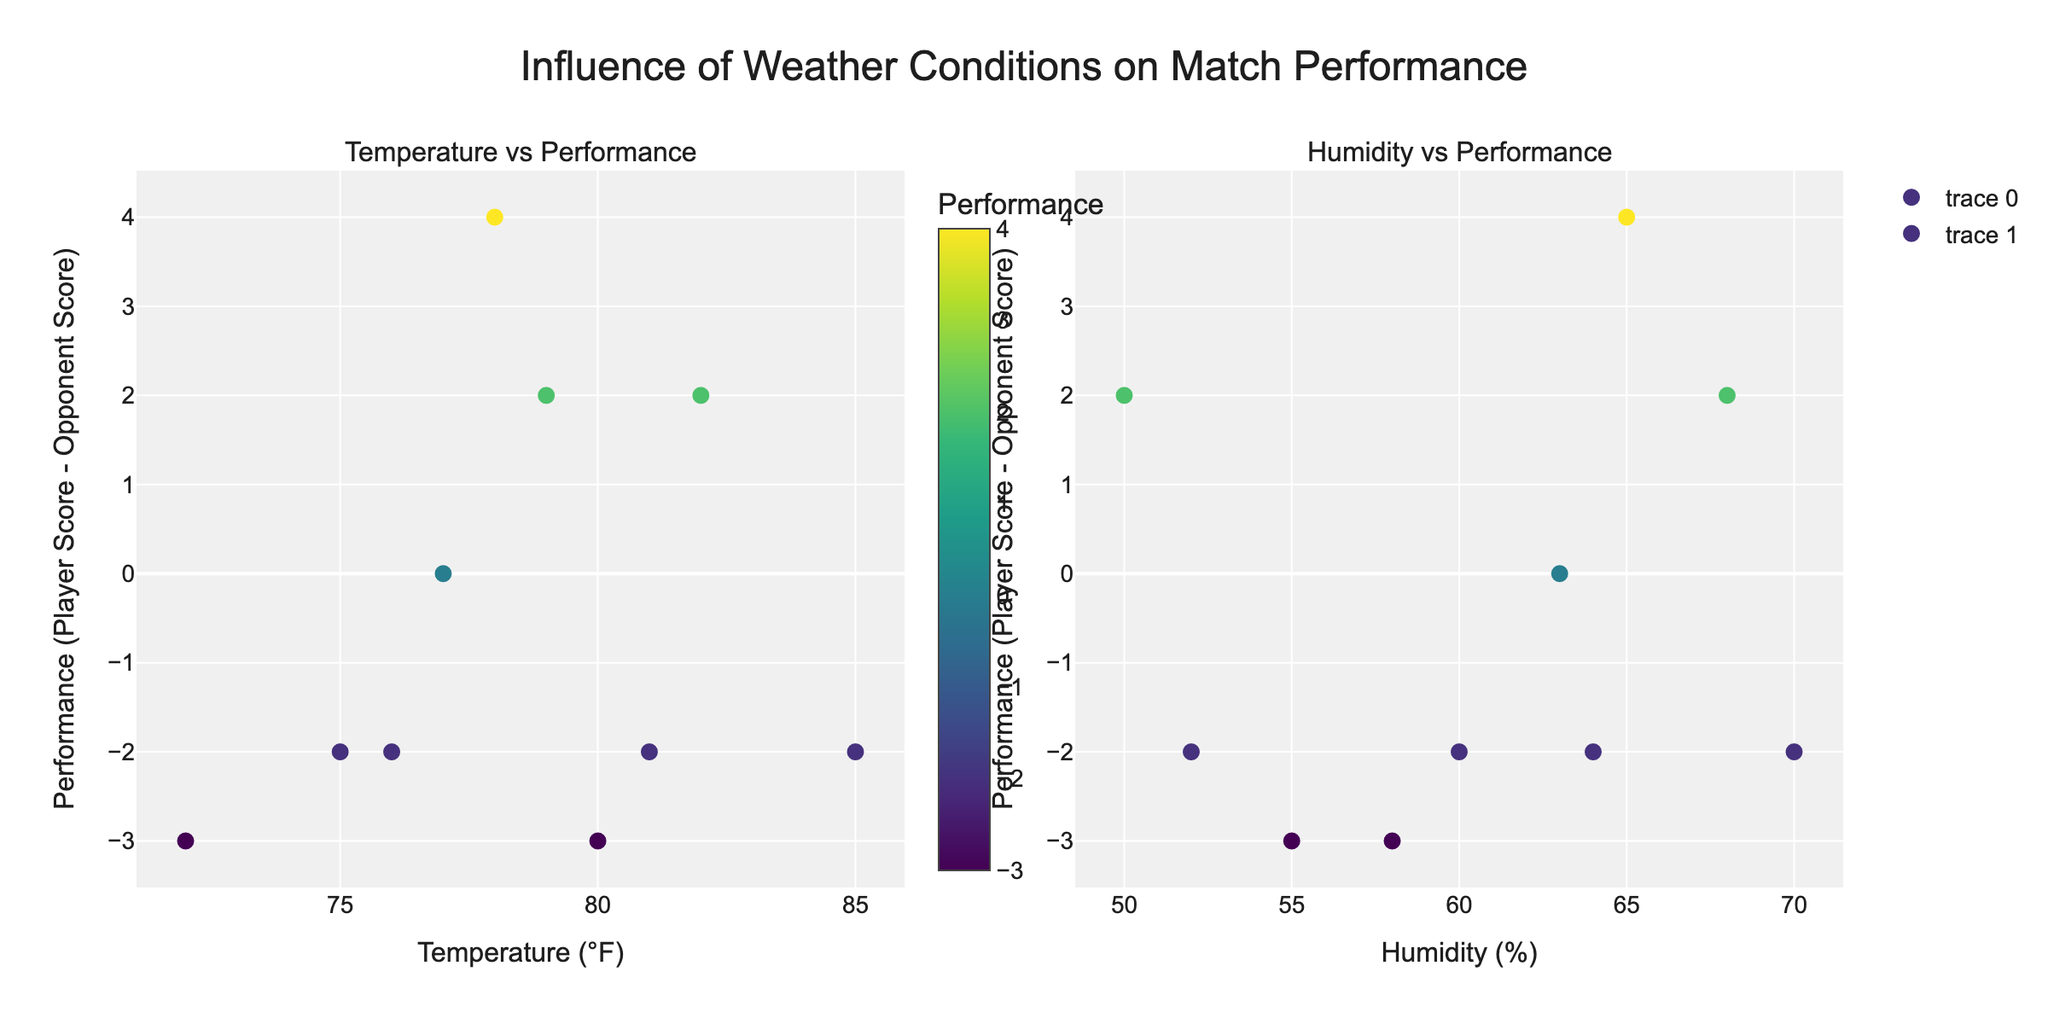What's the title of the plot? The title is displayed at the top-center of the figure. It reads "Influence of Weather Conditions on Match Performance".
Answer: Influence of Weather Conditions on Match Performance Which axis represents Temperature in the subplot? Looking at the figure, the temperature values (in °F) are plotted on the horizontal axis (x-axis) of the left subplot.
Answer: The horizontal axis of the left subplot How is performance measured on the y-axis? The y-axis for both subplots represents performance, calculated as the difference between PlayerScore and OpponentScore.
Answer: Difference between PlayerScore and OpponentScore What color scale is used to represent performance? The color of the markers varies based on performance, using a 'Viridis' color scale. This is shown in the left subplot's color bar.
Answer: Viridis Which match had the highest temperature? By checking the highest data point on the x-axis of the left subplot, we see that the match against Stefanos Tsitsipas had the highest temperature of 85°F.
Answer: Match against Stefanos Tsitsipas Is there a match where John's performance was zero? By looking for a marker on the y-axis at zero in either subplot, we find this occurred in the match against Dominic Thiem.
Answer: Match against Dominic Thiem How does performance appear to change with increasing temperature? By observing the scatter of points in the left subplot, there is no clear upward or downward trend in performance with increasing temperature.
Answer: No clear trend What is the highest performance score recorded, and against which opponent? Identify the highest y-value in either subplot; the highest performance (+4) occurred against Andy Murray.
Answer: +4 against Andy Murray How does performance vary with changes in humidity? Observing the right subplot, performance does not show a clear pattern or trend with humidity changes, as points are scattered.
Answer: No clear pattern Which match had the highest humidity? By checking the highest data point on the x-axis of the right subplot, we see that the match against Stefanos Tsitsipas had the highest humidity of 70%.
Answer: Match against Stefanos Tsitsipas 